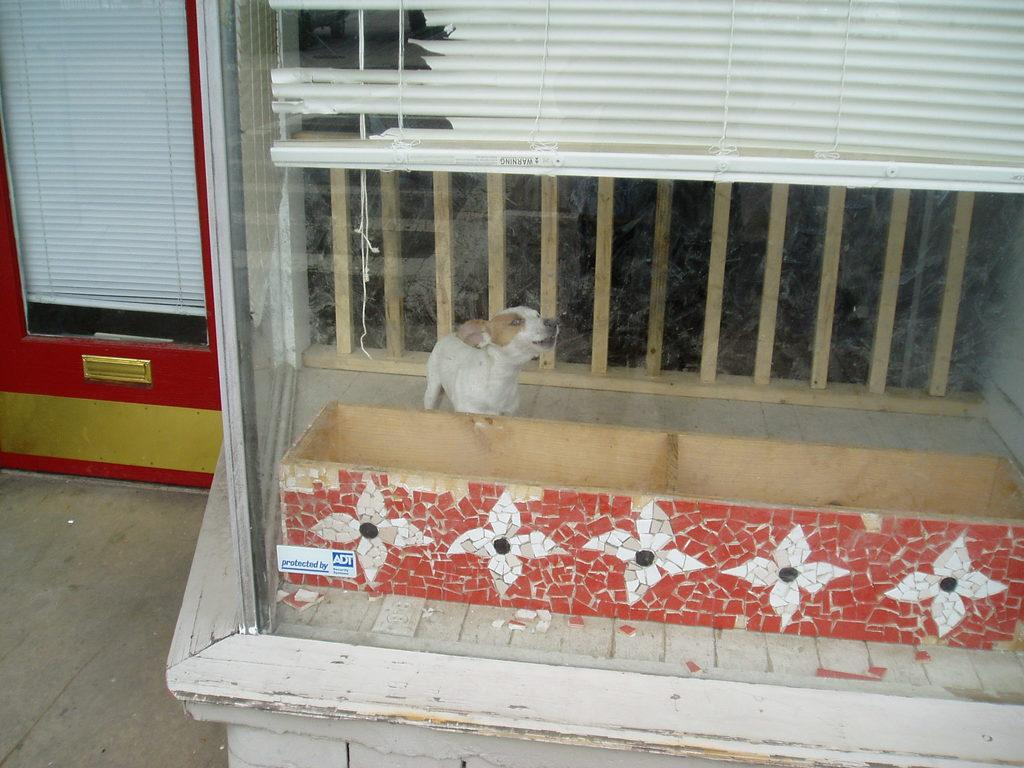What type of animal is in the image? There is an animal in the image, but its specific type cannot be determined from the provided facts. What colors are present on the animal? The animal is in white and cream color. What can be seen in the background of the image? There is a wooden railing and a window blind in the background of the image. What object is in front of the animal? There is a glass in front of the animal. What type of baseball game is the animal attending in the image? There is no baseball game or any reference to baseball in the image. Does the animal appear to be feeling any shame in the image? There is no indication of the animal's emotions or feelings in the image. 